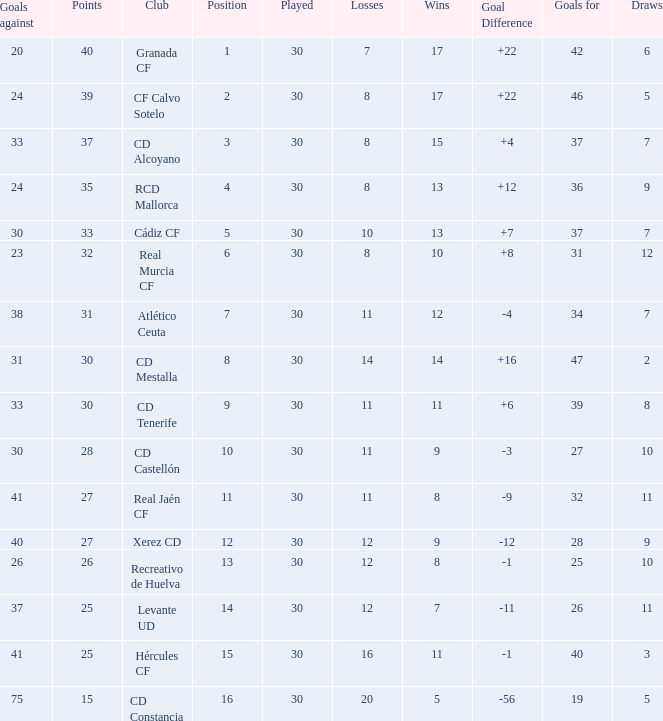Which Wins have a Goal Difference larger than 12, and a Club of granada cf, and Played larger than 30? None. 